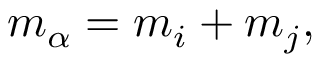<formula> <loc_0><loc_0><loc_500><loc_500>m _ { \alpha } = m _ { i } + m _ { j } ,</formula> 